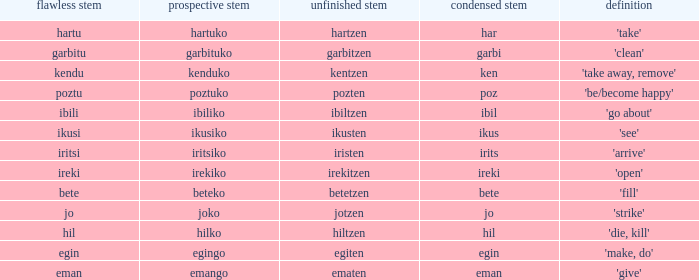What is the perfect stem for pozten? Poztu. 